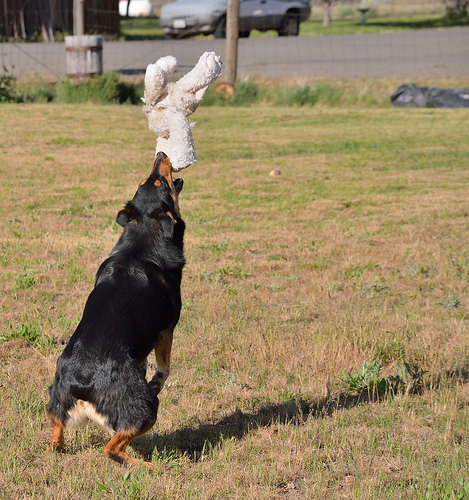<image>
Can you confirm if the dog is on the grass? Yes. Looking at the image, I can see the dog is positioned on top of the grass, with the grass providing support. Where is the dog in relation to the play? Is it in the play? Yes. The dog is contained within or inside the play, showing a containment relationship. 